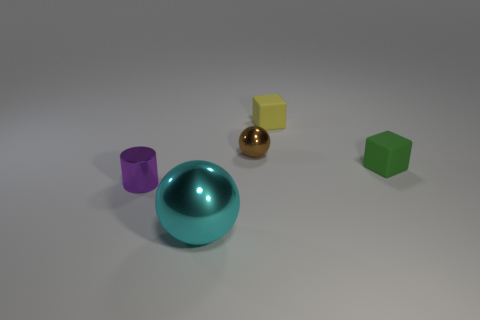Subtract all green blocks. How many blocks are left? 1 Add 2 tiny purple shiny objects. How many objects exist? 7 Subtract all yellow metal balls. Subtract all small brown spheres. How many objects are left? 4 Add 2 small yellow matte cubes. How many small yellow matte cubes are left? 3 Add 2 brown metallic balls. How many brown metallic balls exist? 3 Subtract 0 gray cylinders. How many objects are left? 5 Subtract all blocks. How many objects are left? 3 